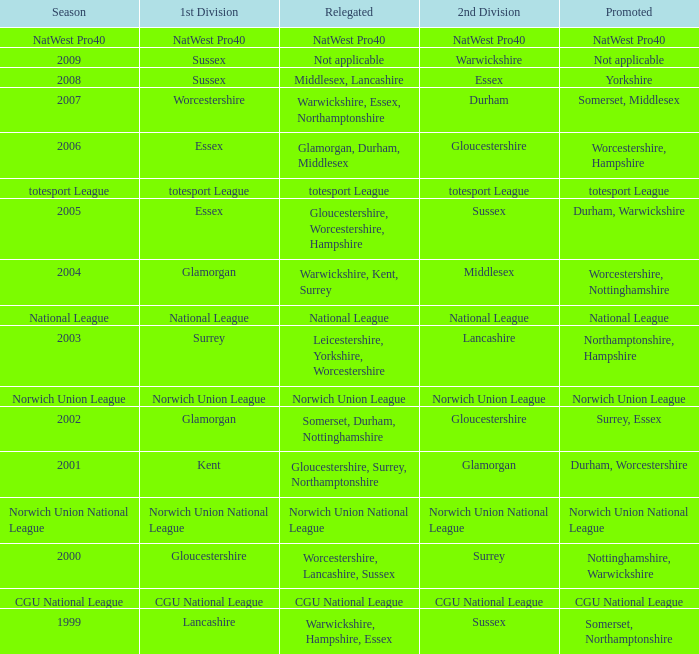What was downgraded in the 2006 season? Glamorgan, Durham, Middlesex. 